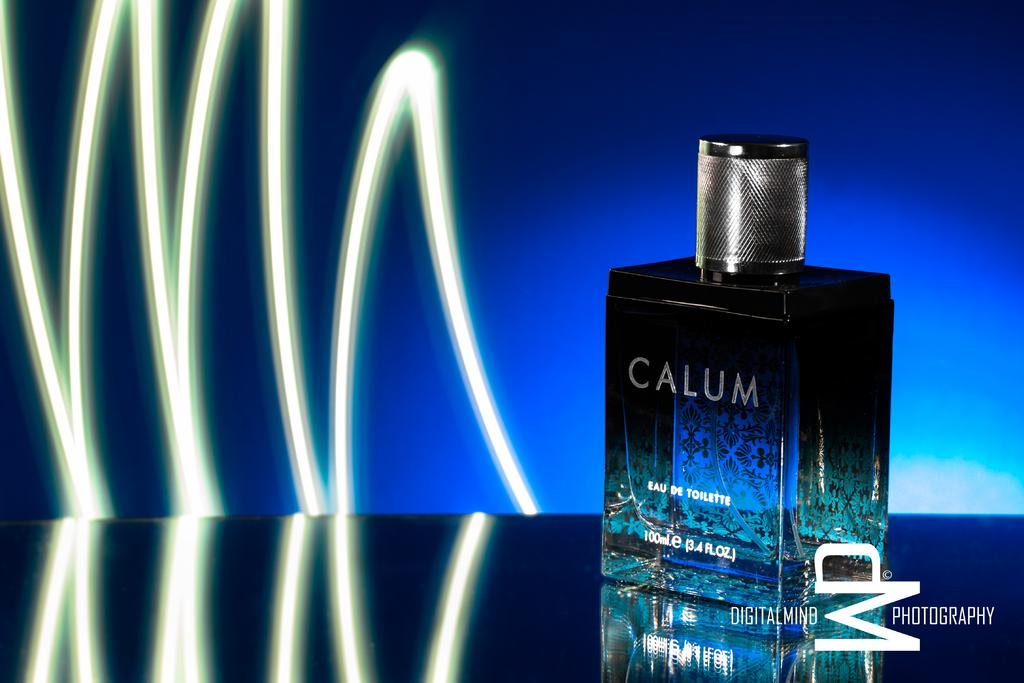<image>
Summarize the visual content of the image. A bottle of Calum Eau de toilette was photographed by WP Photography. 